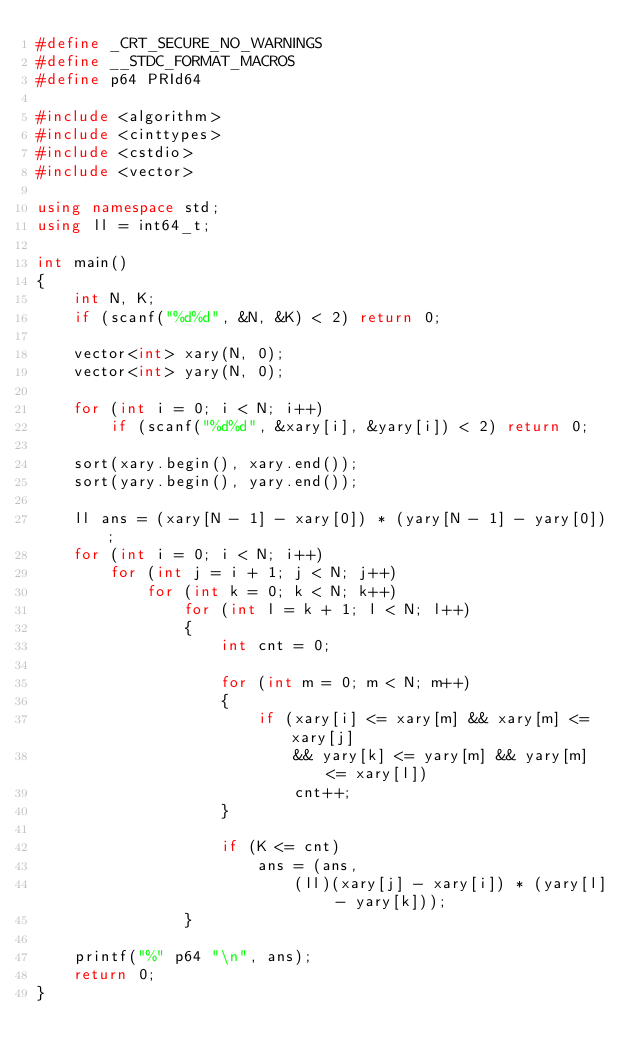Convert code to text. <code><loc_0><loc_0><loc_500><loc_500><_C++_>#define _CRT_SECURE_NO_WARNINGS
#define __STDC_FORMAT_MACROS
#define p64 PRId64

#include <algorithm>
#include <cinttypes>
#include <cstdio>
#include <vector>

using namespace std;
using ll = int64_t;

int main()
{
    int N, K;
    if (scanf("%d%d", &N, &K) < 2) return 0;

    vector<int> xary(N, 0);
    vector<int> yary(N, 0);

    for (int i = 0; i < N; i++)
        if (scanf("%d%d", &xary[i], &yary[i]) < 2) return 0;

    sort(xary.begin(), xary.end());
    sort(yary.begin(), yary.end());

    ll ans = (xary[N - 1] - xary[0]) * (yary[N - 1] - yary[0]);
    for (int i = 0; i < N; i++)
        for (int j = i + 1; j < N; j++)
            for (int k = 0; k < N; k++)
                for (int l = k + 1; l < N; l++)
                {
                    int cnt = 0;

                    for (int m = 0; m < N; m++)
                    {
                        if (xary[i] <= xary[m] && xary[m] <= xary[j]
                            && yary[k] <= yary[m] && yary[m] <= xary[l])
                            cnt++;
                    }

                    if (K <= cnt)
                        ans = (ans,
                            (ll)(xary[j] - xary[i]) * (yary[l] - yary[k]));
                }

    printf("%" p64 "\n", ans);
    return 0;
}</code> 